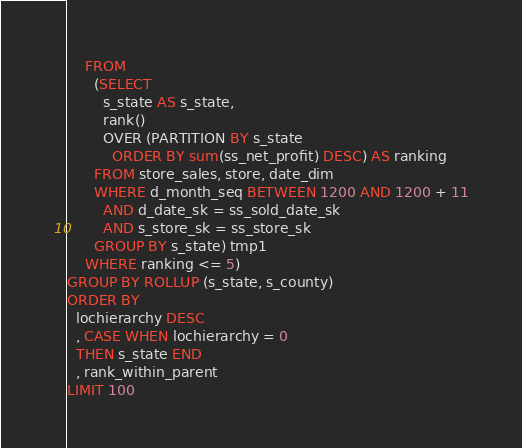Convert code to text. <code><loc_0><loc_0><loc_500><loc_500><_SQL_>    FROM
      (SELECT
        s_state AS s_state,
        rank()
        OVER (PARTITION BY s_state
          ORDER BY sum(ss_net_profit) DESC) AS ranking
      FROM store_sales, store, date_dim
      WHERE d_month_seq BETWEEN 1200 AND 1200 + 11
        AND d_date_sk = ss_sold_date_sk
        AND s_store_sk = ss_store_sk
      GROUP BY s_state) tmp1
    WHERE ranking <= 5)
GROUP BY ROLLUP (s_state, s_county)
ORDER BY
  lochierarchy DESC
  , CASE WHEN lochierarchy = 0
  THEN s_state END
  , rank_within_parent
LIMIT 100
</code> 